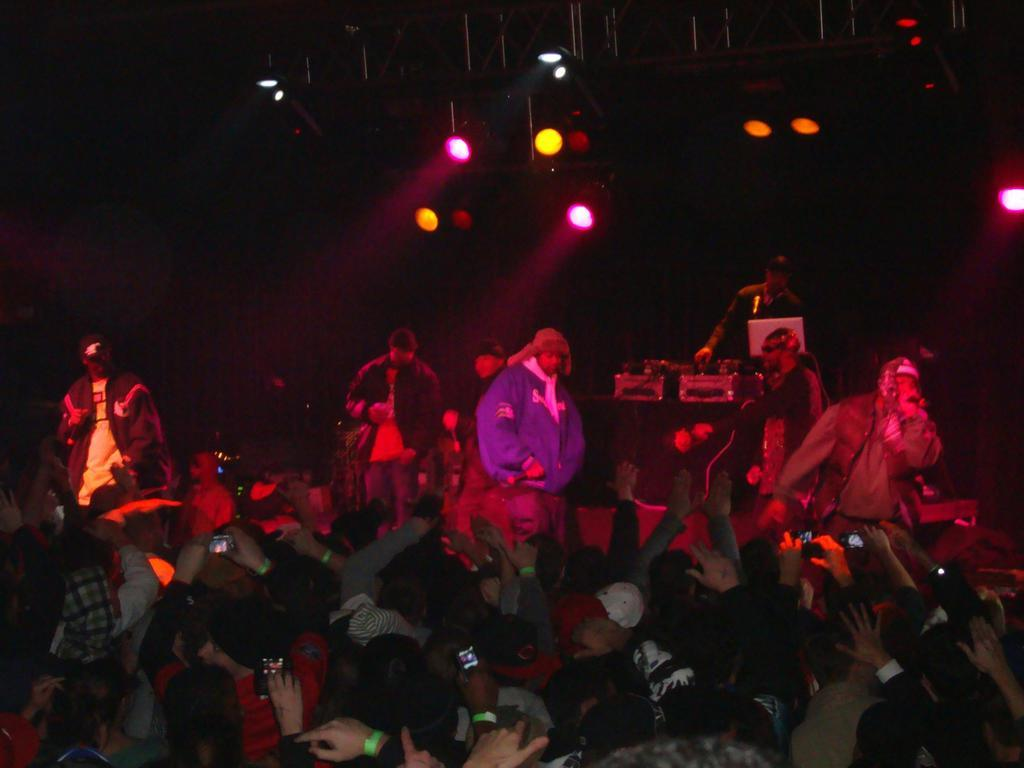What is the main subject of the image? The main subject of the image is a group of people. What are some of the people in the group doing? Some people in the group are holding devices. What can be seen in the background of the image? There are lights and objects visible in the background of the image. What type of meat is being cooked by the people in the image? There is no meat present in the image; it features a group of people holding devices. How many birds can be seen flying in the image? There are no birds visible in the image. 